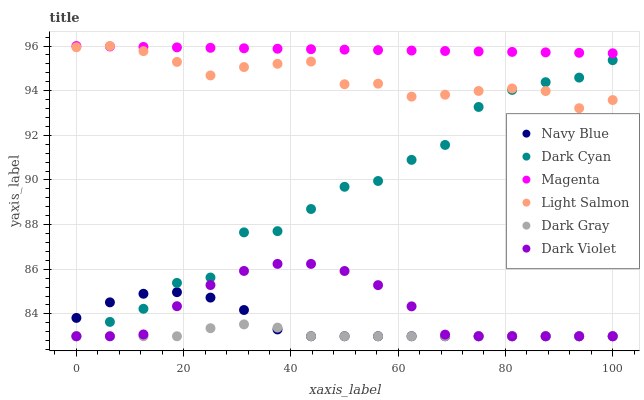Does Dark Gray have the minimum area under the curve?
Answer yes or no. Yes. Does Magenta have the maximum area under the curve?
Answer yes or no. Yes. Does Navy Blue have the minimum area under the curve?
Answer yes or no. No. Does Navy Blue have the maximum area under the curve?
Answer yes or no. No. Is Magenta the smoothest?
Answer yes or no. Yes. Is Dark Cyan the roughest?
Answer yes or no. Yes. Is Navy Blue the smoothest?
Answer yes or no. No. Is Navy Blue the roughest?
Answer yes or no. No. Does Navy Blue have the lowest value?
Answer yes or no. Yes. Does Magenta have the lowest value?
Answer yes or no. No. Does Magenta have the highest value?
Answer yes or no. Yes. Does Navy Blue have the highest value?
Answer yes or no. No. Is Dark Cyan less than Magenta?
Answer yes or no. Yes. Is Light Salmon greater than Dark Gray?
Answer yes or no. Yes. Does Dark Cyan intersect Navy Blue?
Answer yes or no. Yes. Is Dark Cyan less than Navy Blue?
Answer yes or no. No. Is Dark Cyan greater than Navy Blue?
Answer yes or no. No. Does Dark Cyan intersect Magenta?
Answer yes or no. No. 